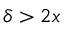Convert formula to latex. <formula><loc_0><loc_0><loc_500><loc_500>\delta > 2 x</formula> 